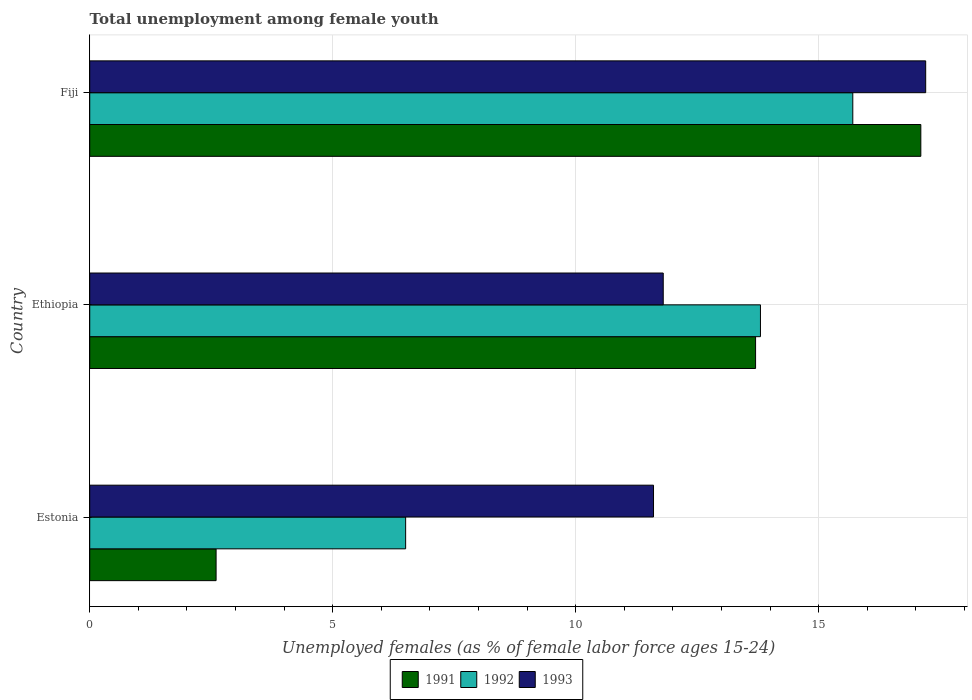How many groups of bars are there?
Make the answer very short. 3. Are the number of bars per tick equal to the number of legend labels?
Provide a short and direct response. Yes. Are the number of bars on each tick of the Y-axis equal?
Your response must be concise. Yes. How many bars are there on the 2nd tick from the top?
Your answer should be compact. 3. How many bars are there on the 1st tick from the bottom?
Provide a short and direct response. 3. What is the label of the 2nd group of bars from the top?
Provide a short and direct response. Ethiopia. In how many cases, is the number of bars for a given country not equal to the number of legend labels?
Your answer should be compact. 0. What is the percentage of unemployed females in in 1991 in Ethiopia?
Provide a succinct answer. 13.7. Across all countries, what is the maximum percentage of unemployed females in in 1993?
Make the answer very short. 17.2. Across all countries, what is the minimum percentage of unemployed females in in 1993?
Provide a short and direct response. 11.6. In which country was the percentage of unemployed females in in 1993 maximum?
Your answer should be compact. Fiji. In which country was the percentage of unemployed females in in 1993 minimum?
Offer a very short reply. Estonia. What is the total percentage of unemployed females in in 1991 in the graph?
Your answer should be compact. 33.4. What is the difference between the percentage of unemployed females in in 1991 in Estonia and that in Ethiopia?
Give a very brief answer. -11.1. What is the difference between the percentage of unemployed females in in 1992 in Estonia and the percentage of unemployed females in in 1993 in Ethiopia?
Keep it short and to the point. -5.3. What is the average percentage of unemployed females in in 1991 per country?
Ensure brevity in your answer.  11.13. In how many countries, is the percentage of unemployed females in in 1992 greater than 5 %?
Provide a succinct answer. 3. What is the ratio of the percentage of unemployed females in in 1992 in Estonia to that in Fiji?
Your response must be concise. 0.41. Is the percentage of unemployed females in in 1993 in Estonia less than that in Ethiopia?
Your response must be concise. Yes. What is the difference between the highest and the second highest percentage of unemployed females in in 1991?
Offer a terse response. 3.4. What is the difference between the highest and the lowest percentage of unemployed females in in 1992?
Provide a short and direct response. 9.2. Is the sum of the percentage of unemployed females in in 1993 in Ethiopia and Fiji greater than the maximum percentage of unemployed females in in 1992 across all countries?
Give a very brief answer. Yes. How many bars are there?
Provide a short and direct response. 9. Are the values on the major ticks of X-axis written in scientific E-notation?
Offer a very short reply. No. Does the graph contain any zero values?
Offer a terse response. No. Does the graph contain grids?
Your answer should be very brief. Yes. What is the title of the graph?
Your answer should be compact. Total unemployment among female youth. Does "1967" appear as one of the legend labels in the graph?
Offer a terse response. No. What is the label or title of the X-axis?
Make the answer very short. Unemployed females (as % of female labor force ages 15-24). What is the Unemployed females (as % of female labor force ages 15-24) in 1991 in Estonia?
Provide a short and direct response. 2.6. What is the Unemployed females (as % of female labor force ages 15-24) in 1993 in Estonia?
Provide a succinct answer. 11.6. What is the Unemployed females (as % of female labor force ages 15-24) of 1991 in Ethiopia?
Your answer should be compact. 13.7. What is the Unemployed females (as % of female labor force ages 15-24) in 1992 in Ethiopia?
Offer a very short reply. 13.8. What is the Unemployed females (as % of female labor force ages 15-24) in 1993 in Ethiopia?
Make the answer very short. 11.8. What is the Unemployed females (as % of female labor force ages 15-24) in 1991 in Fiji?
Offer a terse response. 17.1. What is the Unemployed females (as % of female labor force ages 15-24) of 1992 in Fiji?
Your response must be concise. 15.7. What is the Unemployed females (as % of female labor force ages 15-24) of 1993 in Fiji?
Keep it short and to the point. 17.2. Across all countries, what is the maximum Unemployed females (as % of female labor force ages 15-24) of 1991?
Provide a short and direct response. 17.1. Across all countries, what is the maximum Unemployed females (as % of female labor force ages 15-24) of 1992?
Your answer should be very brief. 15.7. Across all countries, what is the maximum Unemployed females (as % of female labor force ages 15-24) in 1993?
Make the answer very short. 17.2. Across all countries, what is the minimum Unemployed females (as % of female labor force ages 15-24) in 1991?
Offer a very short reply. 2.6. Across all countries, what is the minimum Unemployed females (as % of female labor force ages 15-24) of 1992?
Your response must be concise. 6.5. Across all countries, what is the minimum Unemployed females (as % of female labor force ages 15-24) in 1993?
Provide a succinct answer. 11.6. What is the total Unemployed females (as % of female labor force ages 15-24) of 1991 in the graph?
Offer a terse response. 33.4. What is the total Unemployed females (as % of female labor force ages 15-24) in 1993 in the graph?
Your response must be concise. 40.6. What is the difference between the Unemployed females (as % of female labor force ages 15-24) of 1992 in Estonia and that in Ethiopia?
Keep it short and to the point. -7.3. What is the difference between the Unemployed females (as % of female labor force ages 15-24) in 1993 in Estonia and that in Ethiopia?
Give a very brief answer. -0.2. What is the difference between the Unemployed females (as % of female labor force ages 15-24) of 1991 in Estonia and that in Fiji?
Provide a succinct answer. -14.5. What is the difference between the Unemployed females (as % of female labor force ages 15-24) in 1992 in Estonia and that in Fiji?
Your response must be concise. -9.2. What is the difference between the Unemployed females (as % of female labor force ages 15-24) of 1993 in Estonia and that in Fiji?
Offer a terse response. -5.6. What is the difference between the Unemployed females (as % of female labor force ages 15-24) of 1992 in Ethiopia and that in Fiji?
Provide a short and direct response. -1.9. What is the difference between the Unemployed females (as % of female labor force ages 15-24) in 1993 in Ethiopia and that in Fiji?
Offer a terse response. -5.4. What is the difference between the Unemployed females (as % of female labor force ages 15-24) of 1991 in Estonia and the Unemployed females (as % of female labor force ages 15-24) of 1992 in Ethiopia?
Offer a very short reply. -11.2. What is the difference between the Unemployed females (as % of female labor force ages 15-24) in 1991 in Estonia and the Unemployed females (as % of female labor force ages 15-24) in 1993 in Ethiopia?
Make the answer very short. -9.2. What is the difference between the Unemployed females (as % of female labor force ages 15-24) of 1992 in Estonia and the Unemployed females (as % of female labor force ages 15-24) of 1993 in Ethiopia?
Give a very brief answer. -5.3. What is the difference between the Unemployed females (as % of female labor force ages 15-24) of 1991 in Estonia and the Unemployed females (as % of female labor force ages 15-24) of 1993 in Fiji?
Keep it short and to the point. -14.6. What is the difference between the Unemployed females (as % of female labor force ages 15-24) in 1992 in Estonia and the Unemployed females (as % of female labor force ages 15-24) in 1993 in Fiji?
Keep it short and to the point. -10.7. What is the difference between the Unemployed females (as % of female labor force ages 15-24) in 1991 in Ethiopia and the Unemployed females (as % of female labor force ages 15-24) in 1992 in Fiji?
Your answer should be compact. -2. What is the difference between the Unemployed females (as % of female labor force ages 15-24) in 1991 in Ethiopia and the Unemployed females (as % of female labor force ages 15-24) in 1993 in Fiji?
Give a very brief answer. -3.5. What is the difference between the Unemployed females (as % of female labor force ages 15-24) of 1992 in Ethiopia and the Unemployed females (as % of female labor force ages 15-24) of 1993 in Fiji?
Provide a short and direct response. -3.4. What is the average Unemployed females (as % of female labor force ages 15-24) in 1991 per country?
Your response must be concise. 11.13. What is the average Unemployed females (as % of female labor force ages 15-24) in 1992 per country?
Provide a short and direct response. 12. What is the average Unemployed females (as % of female labor force ages 15-24) in 1993 per country?
Make the answer very short. 13.53. What is the difference between the Unemployed females (as % of female labor force ages 15-24) of 1991 and Unemployed females (as % of female labor force ages 15-24) of 1993 in Estonia?
Offer a terse response. -9. What is the difference between the Unemployed females (as % of female labor force ages 15-24) in 1991 and Unemployed females (as % of female labor force ages 15-24) in 1993 in Ethiopia?
Provide a succinct answer. 1.9. What is the difference between the Unemployed females (as % of female labor force ages 15-24) in 1992 and Unemployed females (as % of female labor force ages 15-24) in 1993 in Ethiopia?
Keep it short and to the point. 2. What is the difference between the Unemployed females (as % of female labor force ages 15-24) in 1991 and Unemployed females (as % of female labor force ages 15-24) in 1992 in Fiji?
Provide a succinct answer. 1.4. What is the difference between the Unemployed females (as % of female labor force ages 15-24) in 1992 and Unemployed females (as % of female labor force ages 15-24) in 1993 in Fiji?
Your answer should be very brief. -1.5. What is the ratio of the Unemployed females (as % of female labor force ages 15-24) in 1991 in Estonia to that in Ethiopia?
Make the answer very short. 0.19. What is the ratio of the Unemployed females (as % of female labor force ages 15-24) of 1992 in Estonia to that in Ethiopia?
Ensure brevity in your answer.  0.47. What is the ratio of the Unemployed females (as % of female labor force ages 15-24) in 1993 in Estonia to that in Ethiopia?
Offer a terse response. 0.98. What is the ratio of the Unemployed females (as % of female labor force ages 15-24) of 1991 in Estonia to that in Fiji?
Provide a short and direct response. 0.15. What is the ratio of the Unemployed females (as % of female labor force ages 15-24) in 1992 in Estonia to that in Fiji?
Provide a succinct answer. 0.41. What is the ratio of the Unemployed females (as % of female labor force ages 15-24) in 1993 in Estonia to that in Fiji?
Your answer should be compact. 0.67. What is the ratio of the Unemployed females (as % of female labor force ages 15-24) of 1991 in Ethiopia to that in Fiji?
Your response must be concise. 0.8. What is the ratio of the Unemployed females (as % of female labor force ages 15-24) in 1992 in Ethiopia to that in Fiji?
Offer a very short reply. 0.88. What is the ratio of the Unemployed females (as % of female labor force ages 15-24) of 1993 in Ethiopia to that in Fiji?
Make the answer very short. 0.69. What is the difference between the highest and the second highest Unemployed females (as % of female labor force ages 15-24) in 1991?
Your answer should be very brief. 3.4. What is the difference between the highest and the lowest Unemployed females (as % of female labor force ages 15-24) in 1991?
Make the answer very short. 14.5. What is the difference between the highest and the lowest Unemployed females (as % of female labor force ages 15-24) of 1992?
Provide a succinct answer. 9.2. What is the difference between the highest and the lowest Unemployed females (as % of female labor force ages 15-24) in 1993?
Your response must be concise. 5.6. 